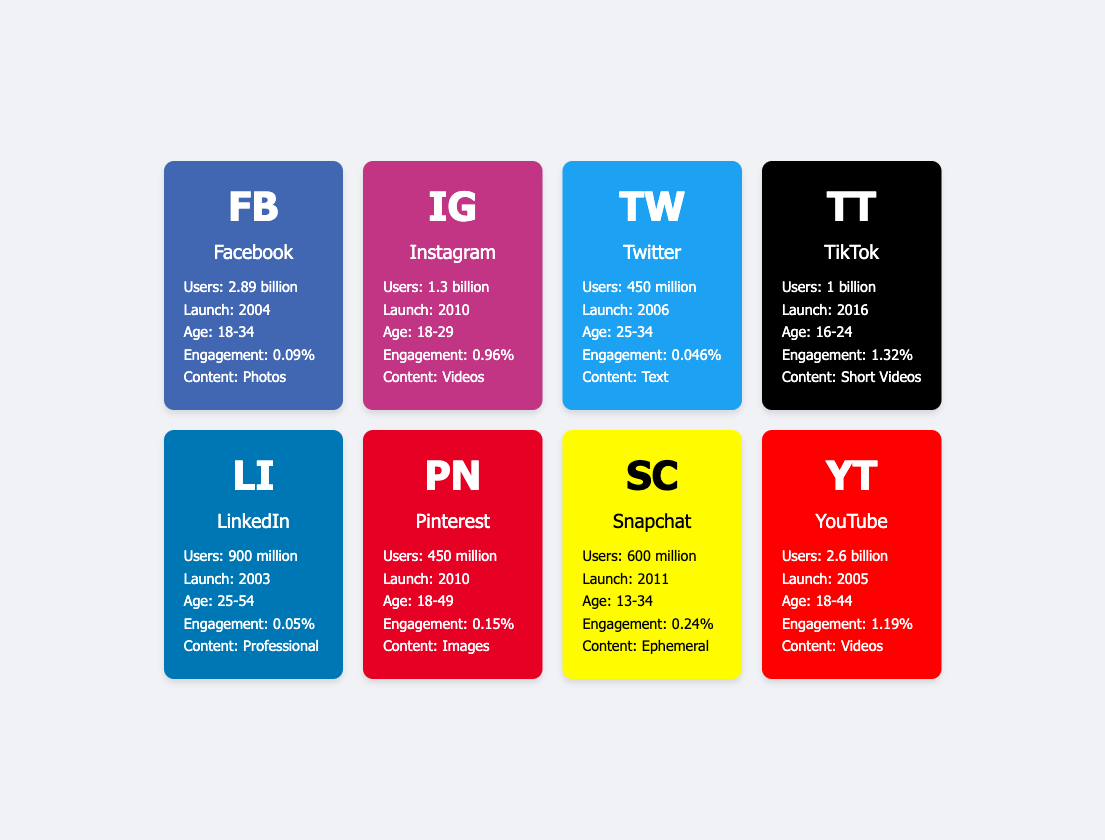What is the user base of YouTube? You can find the user base listed directly under the YouTube entry in the table, which states that it has "2.6 billion" users.
Answer: 2.6 billion Which platform has the highest engagement rate? By comparing the engagement rates from each platform, TikTok has the highest rate at "1.32%", while other platforms have lower rates.
Answer: TikTok How many social media platforms have a user base exceeding 1 billion? From the data, Facebook with "2.89 billion," Instagram with "1.3 billion," and TikTok with "1 billion" are the three platforms that exceed 1 billion users, leading to a total of three platforms.
Answer: 3 Is the primary age group for Snapchat younger than that of LinkedIn? The primary age group for Snapchat is "13-34," while for LinkedIn it is "25-54." As the age range for LinkedIn starts at 25, it indicates that Snapchat's primary age group is indeed younger.
Answer: Yes What is the difference in user base between Facebook and Pinterest? The user base for Facebook is "2.89 billion," and for Pinterest, it is "450 million." To find the difference, convert both values to the same unit: "2.89 billion" - "0.45 billion" = "2.44 billion."
Answer: 2.44 billion Which platform was launched most recently and how old is it? TikTok was launched in "2016," and it can be calculated as of now (2023) it is "7 years old." This is determined by subtracting the launch year from the current year.
Answer: 7 years old Are there more users on Instagram than on Twitter? Instagram has "1.3 billion" users and Twitter has "450 million" users. Since 1.3 billion is greater than 450 million, it confirms that there are more users on Instagram.
Answer: Yes Which two platforms have the same dominant content type? Both YouTube and Instagram have "Videos" as their dominant content type, which can be seen clearly as you compare their profiles in the table.
Answer: YouTube and Instagram What is the average engagement rate of the platforms listed? The engagement rates are 0.09% (Facebook), 0.96% (Instagram), 0.046% (Twitter), 1.32% (TikTok), 0.05% (LinkedIn), 0.15% (Pinterest), 0.24% (Snapchat), and 1.19% (YouTube). To find the average, add all these rates and divide by the number of platforms (8). The total is 4.146%, thus average engagement rate = 4.146% / 8 = 0.51825%.
Answer: 0.51825% 